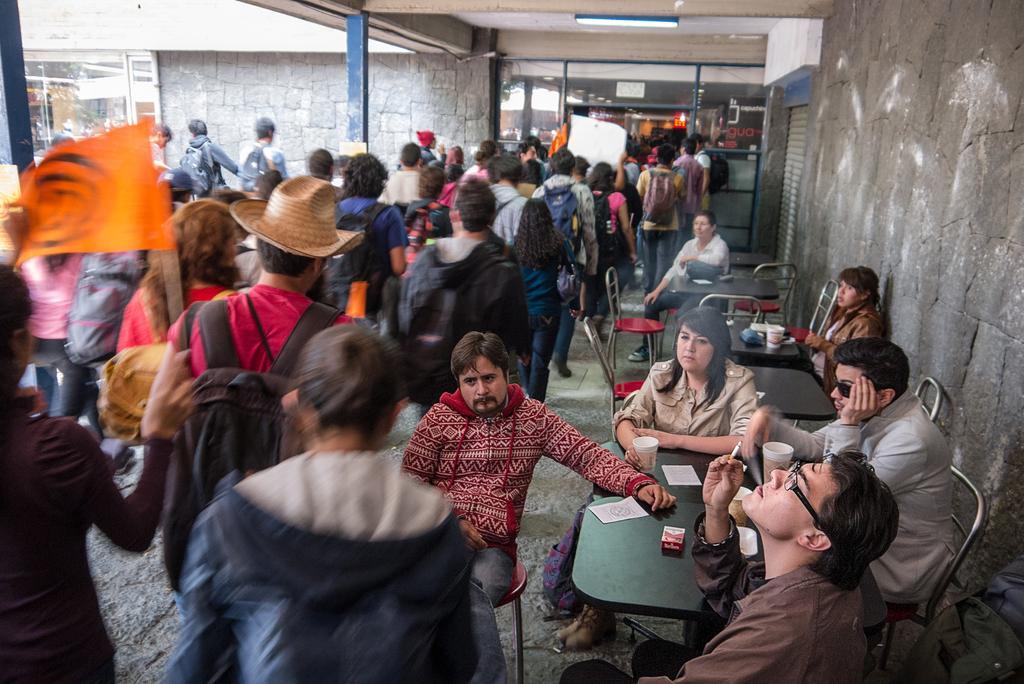Describe this image in one or two sentences. In this image we can see one building, one light attached to the ceiling. There are two glass doors, two flags. So many people are walking, some people are wearing bags and holding different kinds of objects. There are five tables and some chairs near the wall. Six people sitting on chairs and one man is smoking. There are different types of objects on the table. 